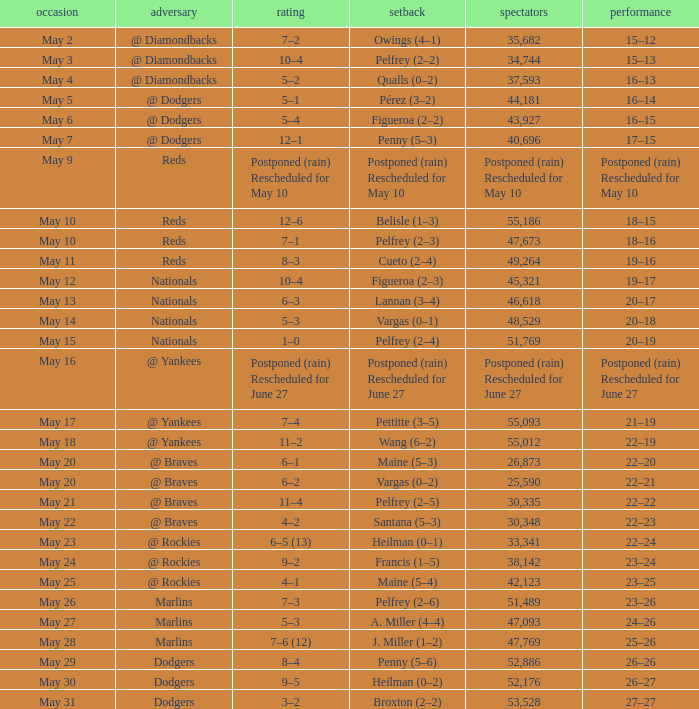Score of postponed (rain) rescheduled for June 27 had what loss? Postponed (rain) Rescheduled for June 27. 